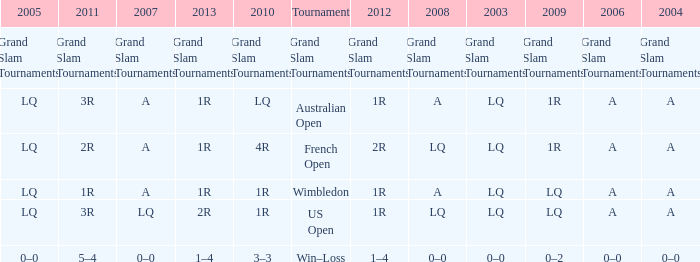Which year has a 2011 of 1r? A. 